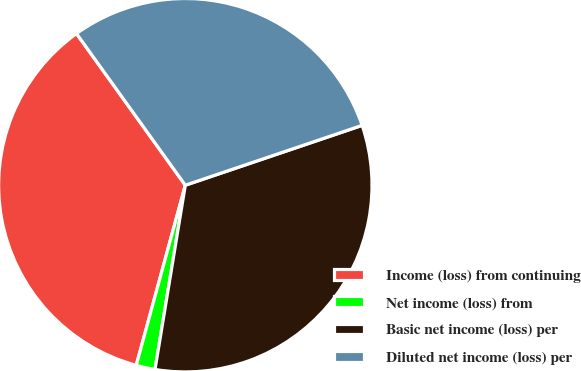<chart> <loc_0><loc_0><loc_500><loc_500><pie_chart><fcel>Income (loss) from continuing<fcel>Net income (loss) from<fcel>Basic net income (loss) per<fcel>Diluted net income (loss) per<nl><fcel>35.86%<fcel>1.64%<fcel>32.79%<fcel>29.71%<nl></chart> 